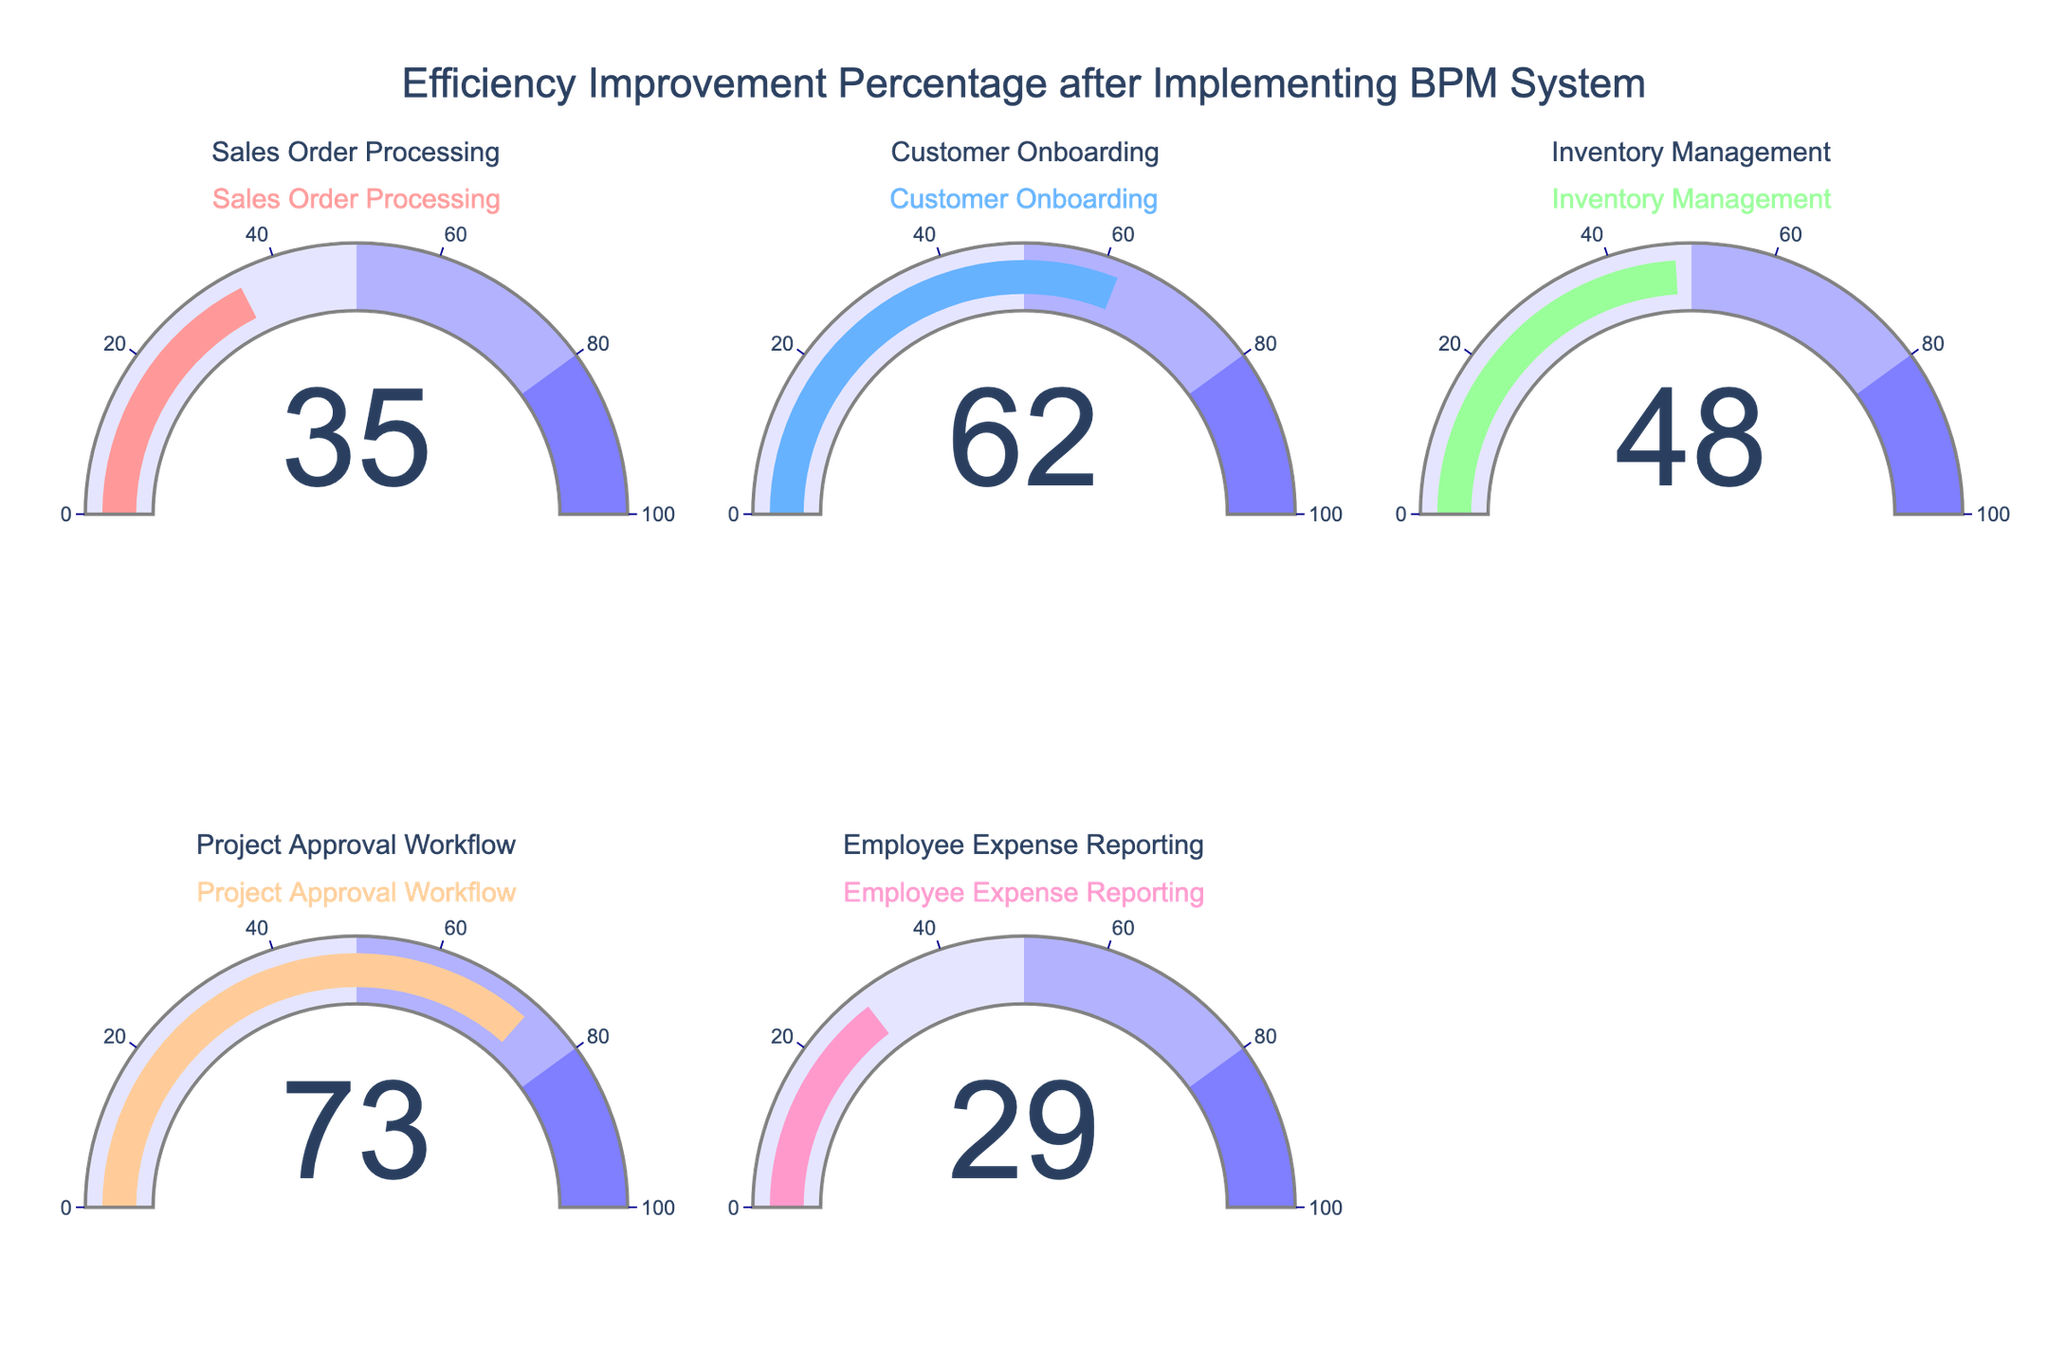What's the highest efficiency improvement percentage displayed? Look at the gauge that indicates the highest number among all gauges. The Project Approval Workflow gauge shows the highest value at 73%.
Answer: 73% Which process has the lowest efficiency improvement percentage? View all the gauges and locate the one with the smallest percentage. The Employee Expense Reporting gauge shows 29%, which is the lowest.
Answer: Employee Expense Reporting How many processes have efficiency improvements greater than 50%? Count the number of gauges with values above 50%. The Customer Onboarding (62%) and Project Approval Workflow (73%) gauges meet this criterion.
Answer: 2 What is the average efficiency improvement percentage across all processes? Sum all the percentages (35 + 62 + 48 + 73 + 29) and divide by the number of processes (5). The calculation is (35 + 62 + 48 + 73 + 29) / 5 = 247 / 5 = 49.4%.
Answer: 49.4% Which processes have efficiency improvement percentages below the average? Calculate the average improvement percentage (49.4%), and identify which gauges show lower values. The Sales Order Processing (35%), Inventory Management (48%), and Employee Expense Reporting (29%) gauges are below average.
Answer: Sales Order Processing, Inventory Management, Employee Expense Reporting What's the difference in efficiency improvement percentages between the highest and lowest values? Subtract the lowest value (29%) from the highest value (73%). The calculation is 73% - 29% = 44%.
Answer: 44% Which two processes show similar efficiency improvements and how much is the difference between their percentages? Identify gauges with close values. The Sales Order Processing (35%) and Employee Expense Reporting (29%) gauges are close, with a difference of 35% - 29% = 6%.
Answer: Sales Order Processing and Employee Expense Reporting, 6% What percentage range contains the most processes? Examine the defined ranges and count processes in each. The range 0-50% contains most processes: Sales Order Processing (35%), Inventory Management (48%), and Employee Expense Reporting (29%).
Answer: 0-50% Which process has the highest efficiency improvement percentage in the range of 50-80%? Identify gauges within this range and note the highest value. The Customer Onboarding gauge shows 62%, which is the highest in this range.
Answer: Customer Onboarding What is the cumulative improvement percentage for all processes? Add all the percentages together. The sum is 35 + 62 + 48 + 73 + 29 = 247%.
Answer: 247% 